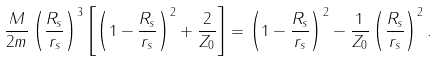Convert formula to latex. <formula><loc_0><loc_0><loc_500><loc_500>\frac { M } { 2 m } \left ( \frac { R _ { s } } { r _ { s } } \right ) ^ { 3 } \left [ \left ( 1 - \frac { R _ { s } } { r _ { s } } \right ) ^ { 2 } + \frac { 2 } { Z _ { 0 } } \right ] = \left ( 1 - \frac { R _ { s } } { r _ { s } } \right ) ^ { 2 } - \frac { 1 } { Z _ { 0 } } \left ( \frac { R _ { s } } { r _ { s } } \right ) ^ { 2 } .</formula> 